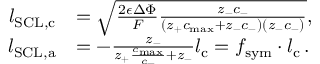<formula> <loc_0><loc_0><loc_500><loc_500>\begin{array} { r l } { l _ { S C L , c } } & { = \sqrt { \frac { 2 \epsilon \Delta \Phi } { F } \frac { z _ { - } c _ { - } } { ( z _ { + } c _ { \max } + z _ { - } c _ { - } ) ( z _ { - } c _ { - } ) } } , } \\ { l _ { S C L , a } } & { = - \frac { z _ { - } } { z _ { + } \frac { c _ { \max } } { c _ { - } } + z _ { - } } l _ { c } = f _ { s y m } \cdot l _ { c } \, . } \end{array}</formula> 